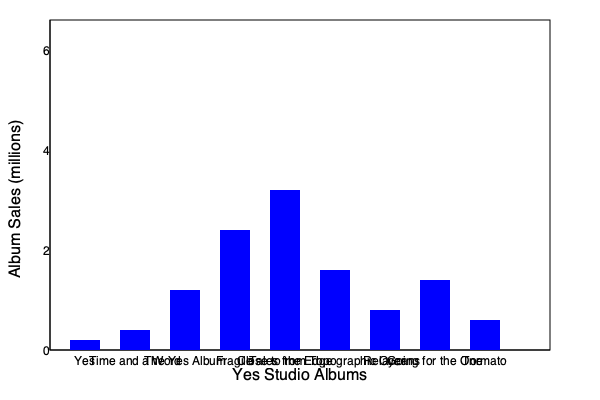Based on the bar graph showing Yes's studio album sales, which album marked the band's commercial breakthrough and approximately how many million copies did it sell? To answer this question, we need to analyze the bar graph of Yes's studio album sales:

1. The graph shows the sales figures for Yes's first nine studio albums in chronological order.
2. We can see a significant increase in sales starting from the third album, "The Yes Album."
3. However, the most dramatic increase occurs with the fourth album, "Fragile."
4. "Fragile" shows a much taller bar compared to its predecessors, indicating a substantial jump in sales.
5. To estimate the sales figure for "Fragile," we can use the y-axis scale:
   - The bar for "Fragile" reaches slightly above the midpoint between 2 million and 4 million.
   - This suggests sales of approximately 3 million copies.
6. The albums following "Fragile" maintain higher sales than the earlier albums, but "Fragile" represents the clear commercial breakthrough.

Therefore, "Fragile" marked Yes's commercial breakthrough, selling approximately 3 million copies.
Answer: Fragile, ~3 million copies 